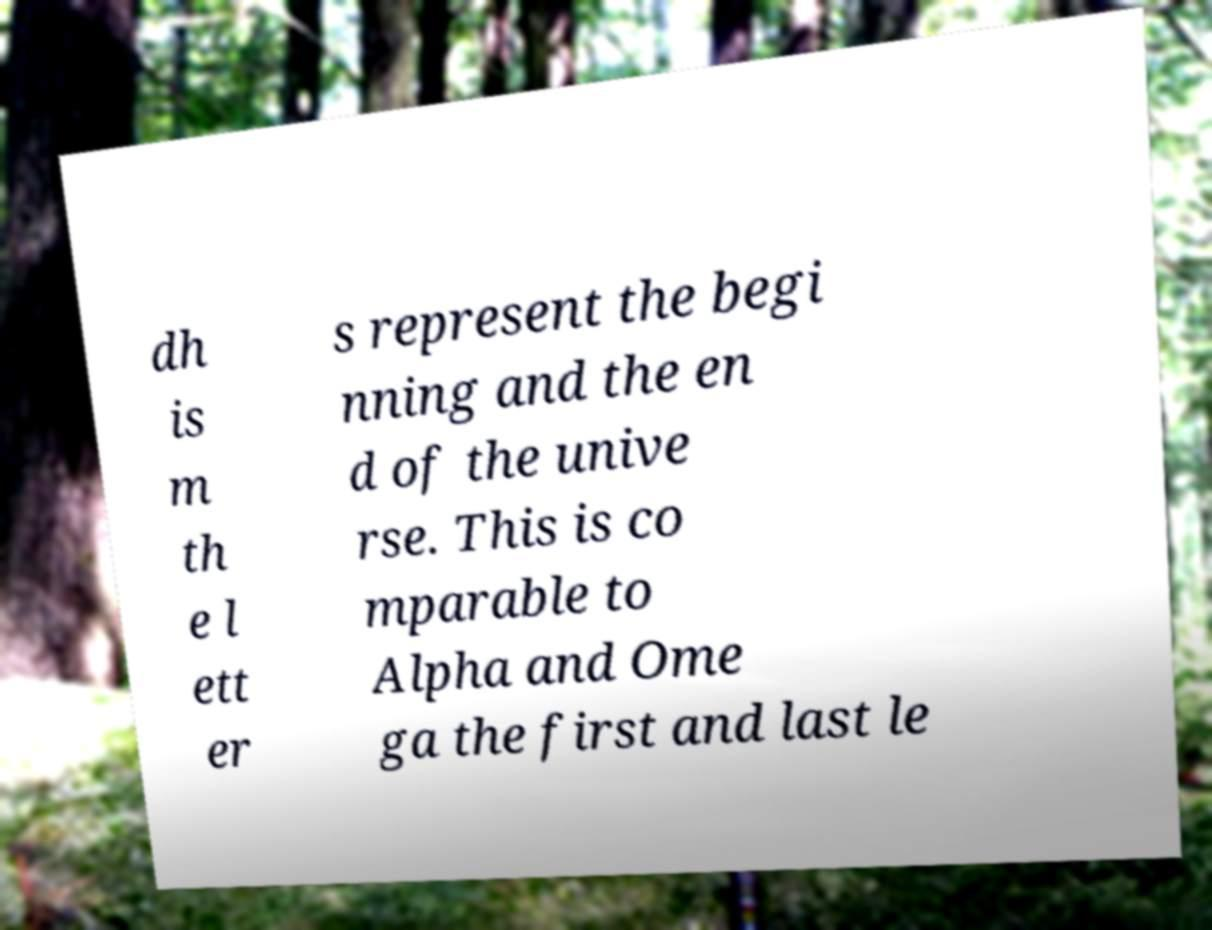For documentation purposes, I need the text within this image transcribed. Could you provide that? dh is m th e l ett er s represent the begi nning and the en d of the unive rse. This is co mparable to Alpha and Ome ga the first and last le 